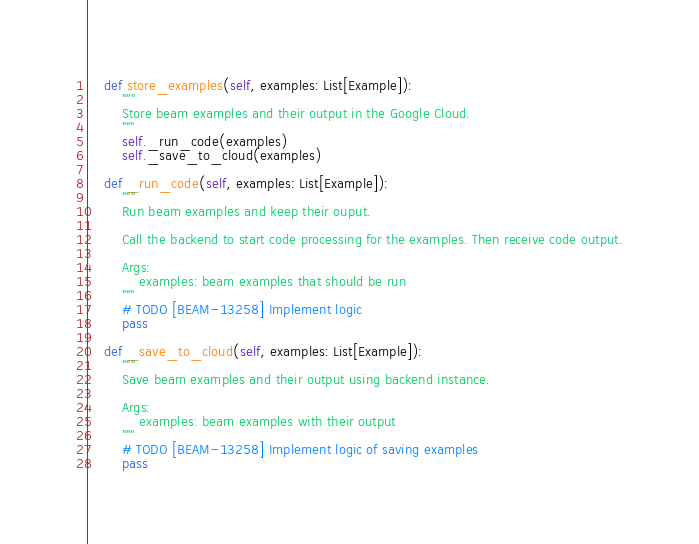Convert code to text. <code><loc_0><loc_0><loc_500><loc_500><_Python_>    def store_examples(self, examples: List[Example]):
        """
        Store beam examples and their output in the Google Cloud.
        """
        self._run_code(examples)
        self._save_to_cloud(examples)

    def _run_code(self, examples: List[Example]):
        """
        Run beam examples and keep their ouput.

        Call the backend to start code processing for the examples. Then receive code output.

        Args:
            examples: beam examples that should be run
        """
        # TODO [BEAM-13258] Implement logic
        pass

    def _save_to_cloud(self, examples: List[Example]):
        """
        Save beam examples and their output using backend instance.

        Args:
            examples: beam examples with their output
        """
        # TODO [BEAM-13258] Implement logic of saving examples
        pass
</code> 